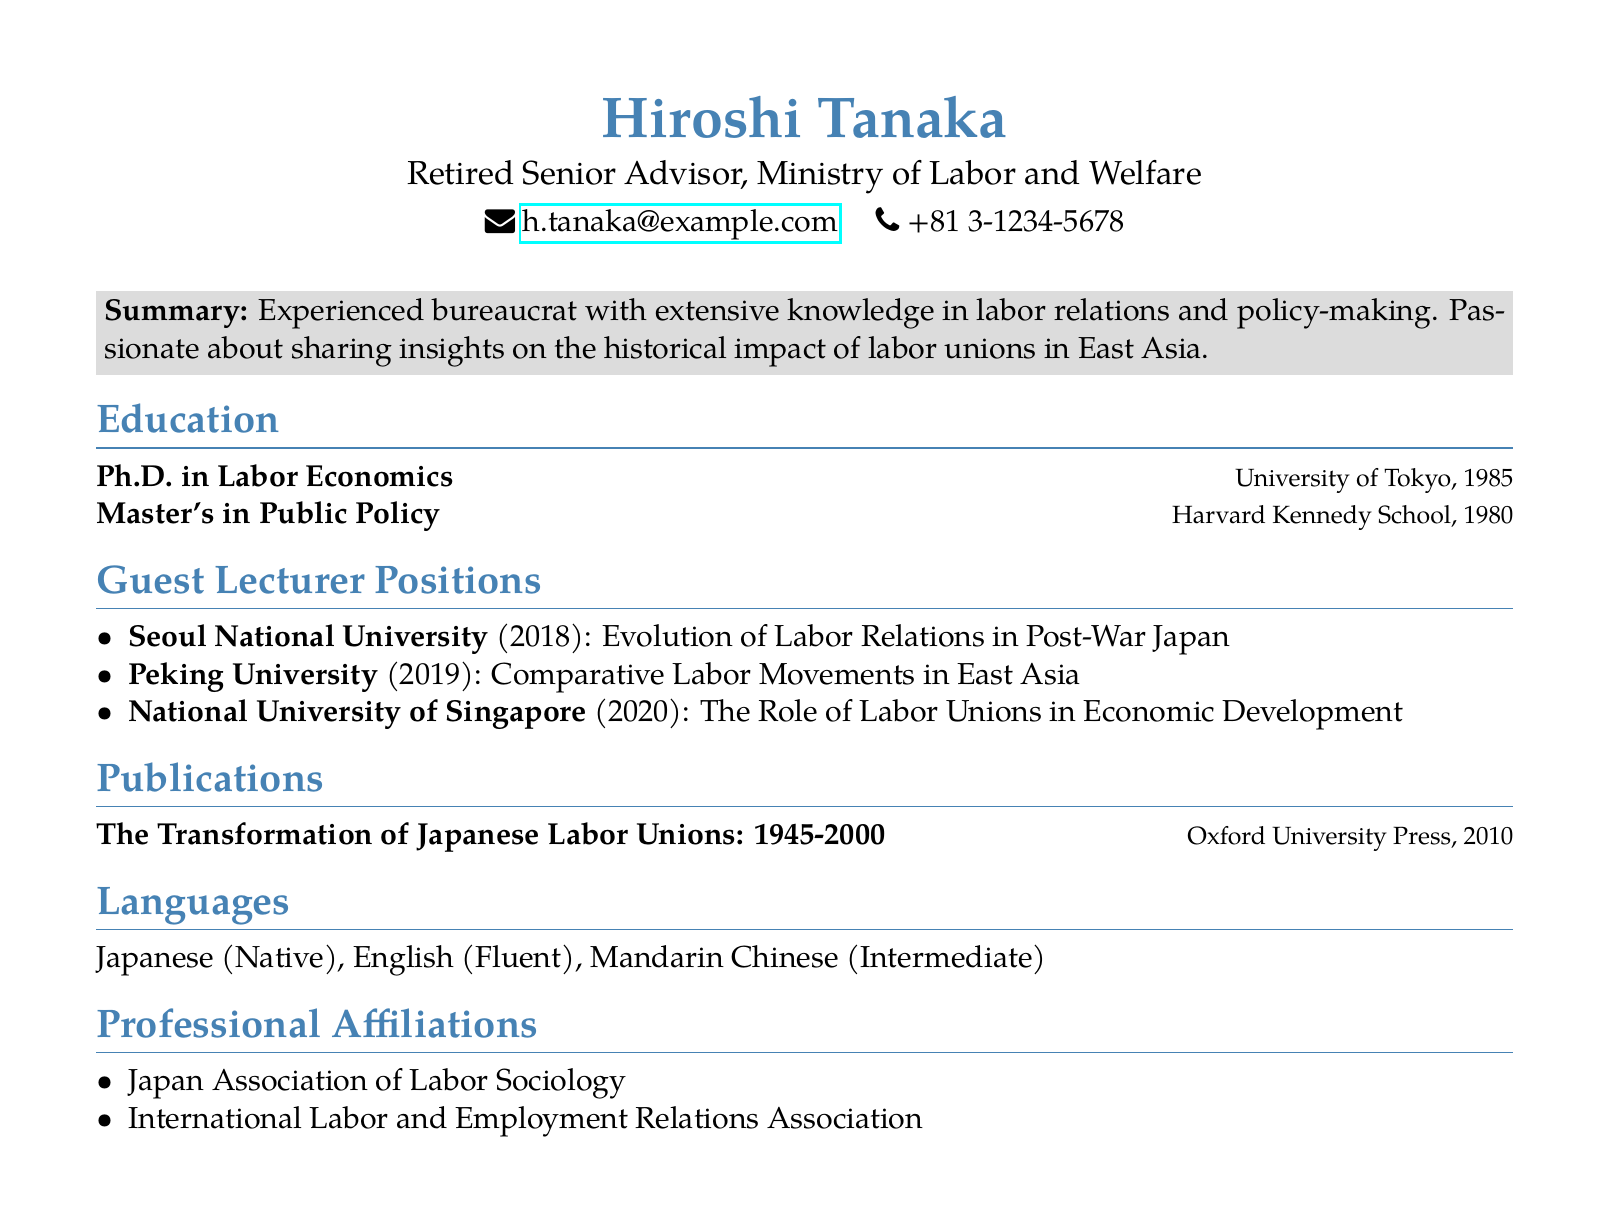what is the name of the individual? The name of the individual is stated at the top of the document.
Answer: Hiroshi Tanaka what is the title of the individual? The title is presented under the name at the beginning of the document.
Answer: Retired Senior Advisor, Ministry of Labor and Welfare how many languages does the individual speak? The languages section lists the number of languages known by the individual.
Answer: Three in which year did the individual complete their Ph.D.? The education background specifies the year the Ph.D. was awarded.
Answer: 1985 which institution did the individual guest lecture at in 2020? The guest lecturer positions list the institutions along with the corresponding years.
Answer: National University of Singapore what is the focus of the course taught at Peking University? The document provides details about the course titles taught at each institution.
Answer: Comparative Labor Movements in East Asia how many professional affiliations does the individual have? The professional affiliations section counts the number of listed affiliations.
Answer: Two what is the title of the individual's publication? The publications section specifies the title of a significant work authored by the individual.
Answer: The Transformation of Japanese Labor Unions: 1945-2000 which institution offered a course on the role of labor unions? An inquiry about the specific course that mentions labor unions in the guest lecturer positions.
Answer: National University of Singapore 